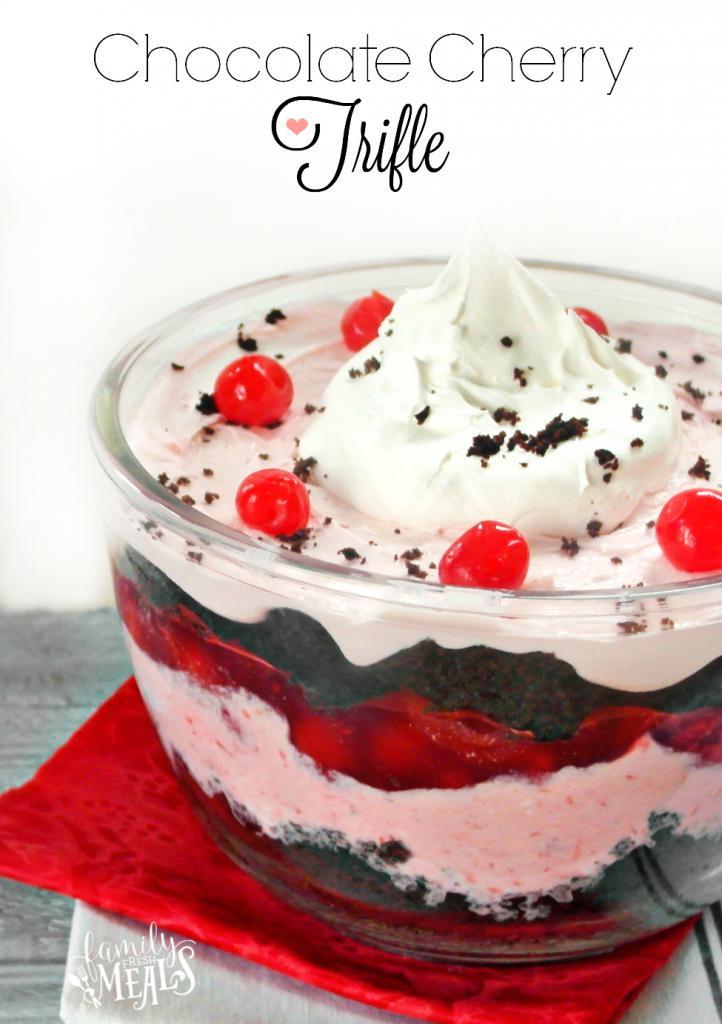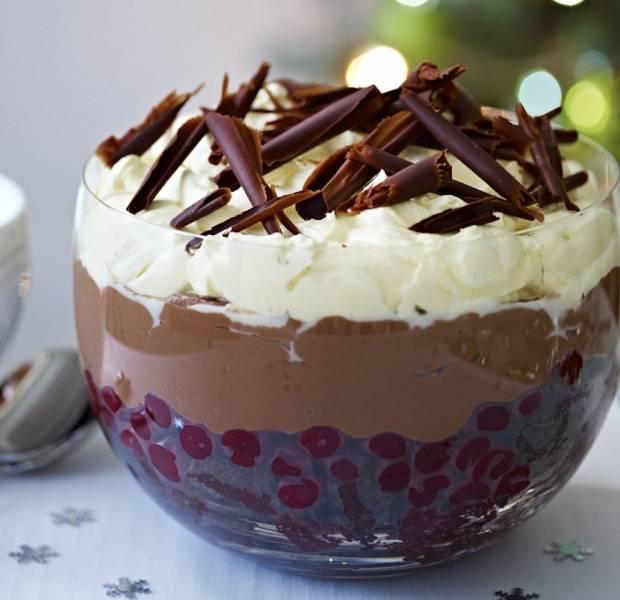The first image is the image on the left, the second image is the image on the right. Assess this claim about the two images: "there are two trifles in the image pair". Correct or not? Answer yes or no. Yes. The first image is the image on the left, the second image is the image on the right. Given the left and right images, does the statement "In the right image, there are at least three chocolate deserts." hold true? Answer yes or no. No. 